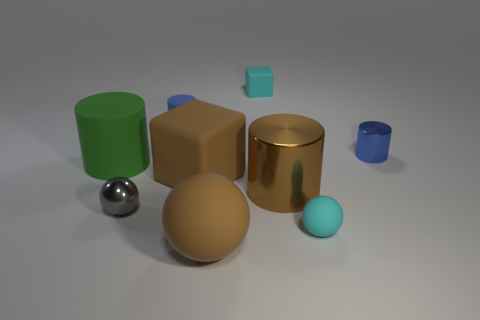Is the number of tiny rubber things that are in front of the small blue matte thing greater than the number of things that are behind the big matte block?
Provide a succinct answer. No. There is a sphere in front of the small cyan object that is in front of the large cylinder that is to the left of the tiny gray metal thing; how big is it?
Keep it short and to the point. Large. Are there any other metal balls that have the same color as the shiny sphere?
Provide a succinct answer. No. What number of purple matte cylinders are there?
Give a very brief answer. 0. The cyan object that is in front of the block behind the metallic cylinder to the right of the small matte ball is made of what material?
Give a very brief answer. Rubber. Is there a block made of the same material as the large brown cylinder?
Ensure brevity in your answer.  No. Is the small cyan block made of the same material as the big green cylinder?
Your answer should be compact. Yes. What number of blocks are either cyan rubber objects or large brown rubber things?
Your answer should be compact. 2. The big sphere that is made of the same material as the big block is what color?
Your response must be concise. Brown. Is the number of brown rubber things less than the number of small green matte balls?
Your answer should be compact. No. 